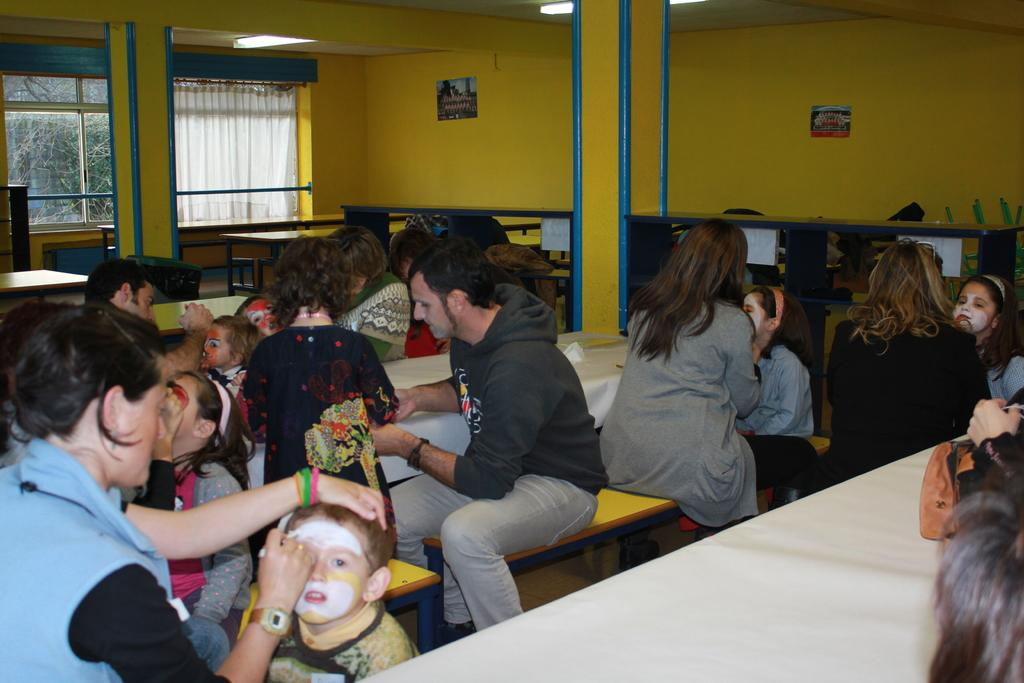Who is present in the image? There are small kids in the image. Where are the kids located? The kids are sitting in a classroom. What are the kids doing in the image? The kids are decorating their faces with paints. What can be seen on the wall in the background? There is a yellow color wall in the background. What is on the wall near the window? There is a glass window on the wall. What type of window treatment is present in the image? There is a white curtain associated with the window. What type of toad can be seen sitting on the teacher's desk in the image? There is no toad present in the image; it is a classroom with kids decorating their faces with paints. 